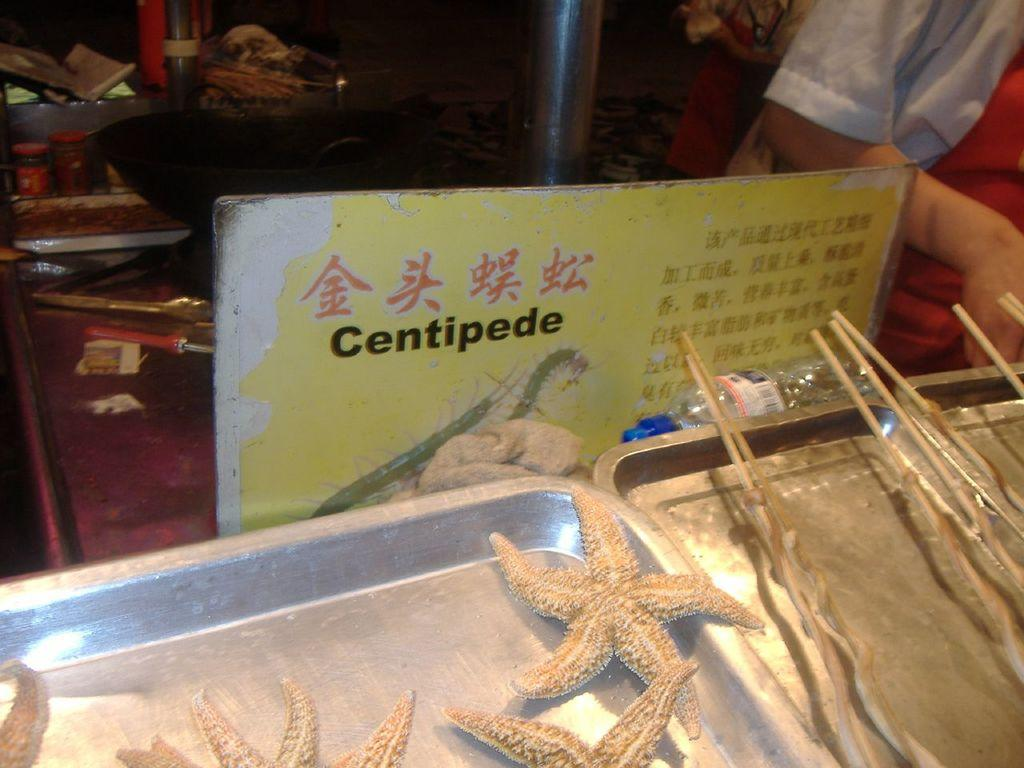What type of objects are made of steel in the image? There are steel objects in the image, but the specific type cannot be determined without more information. What is written on the board in the image? There is a board with text in the image, but the content of the text cannot be determined without more information. What kind of food items can be seen in the image? There are food items in the image, but the specific type cannot be determined without more information. Whose hand is visible in the image? A human hand is visible in the image, but it is not possible to determine whose hand it is without more information. How many grapes are hanging from the tail of the animal in the image? There is no animal or grapes present in the image. 